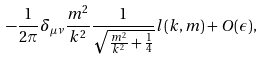Convert formula to latex. <formula><loc_0><loc_0><loc_500><loc_500>- \frac { 1 } { 2 \pi } \delta _ { \mu \nu } \frac { m ^ { 2 } } { k ^ { 2 } } \frac { 1 } { \sqrt { \frac { m ^ { 2 } } { k ^ { 2 } } + \frac { 1 } { 4 } } } l ( k , m ) + O ( \epsilon ) ,</formula> 